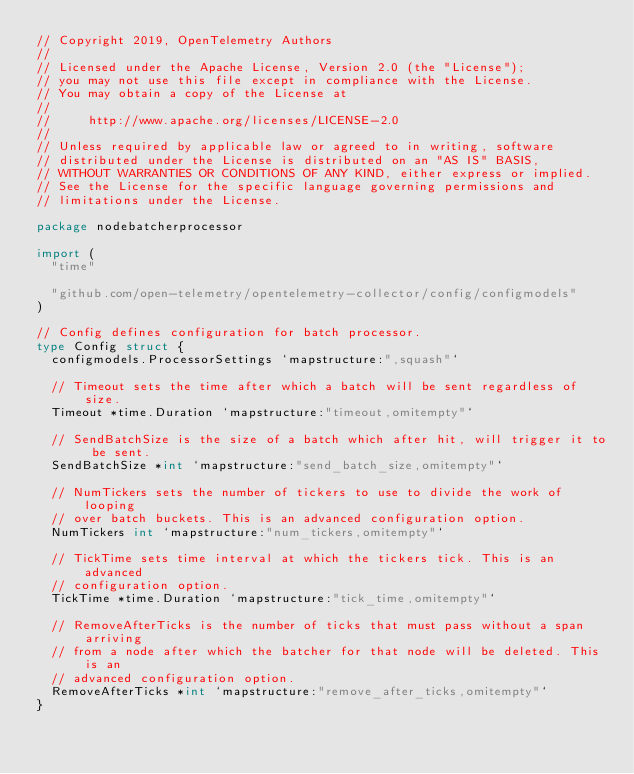<code> <loc_0><loc_0><loc_500><loc_500><_Go_>// Copyright 2019, OpenTelemetry Authors
//
// Licensed under the Apache License, Version 2.0 (the "License");
// you may not use this file except in compliance with the License.
// You may obtain a copy of the License at
//
//     http://www.apache.org/licenses/LICENSE-2.0
//
// Unless required by applicable law or agreed to in writing, software
// distributed under the License is distributed on an "AS IS" BASIS,
// WITHOUT WARRANTIES OR CONDITIONS OF ANY KIND, either express or implied.
// See the License for the specific language governing permissions and
// limitations under the License.

package nodebatcherprocessor

import (
	"time"

	"github.com/open-telemetry/opentelemetry-collector/config/configmodels"
)

// Config defines configuration for batch processor.
type Config struct {
	configmodels.ProcessorSettings `mapstructure:",squash"`

	// Timeout sets the time after which a batch will be sent regardless of size.
	Timeout *time.Duration `mapstructure:"timeout,omitempty"`

	// SendBatchSize is the size of a batch which after hit, will trigger it to be sent.
	SendBatchSize *int `mapstructure:"send_batch_size,omitempty"`

	// NumTickers sets the number of tickers to use to divide the work of looping
	// over batch buckets. This is an advanced configuration option.
	NumTickers int `mapstructure:"num_tickers,omitempty"`

	// TickTime sets time interval at which the tickers tick. This is an advanced
	// configuration option.
	TickTime *time.Duration `mapstructure:"tick_time,omitempty"`

	// RemoveAfterTicks is the number of ticks that must pass without a span arriving
	// from a node after which the batcher for that node will be deleted. This is an
	// advanced configuration option.
	RemoveAfterTicks *int `mapstructure:"remove_after_ticks,omitempty"`
}
</code> 